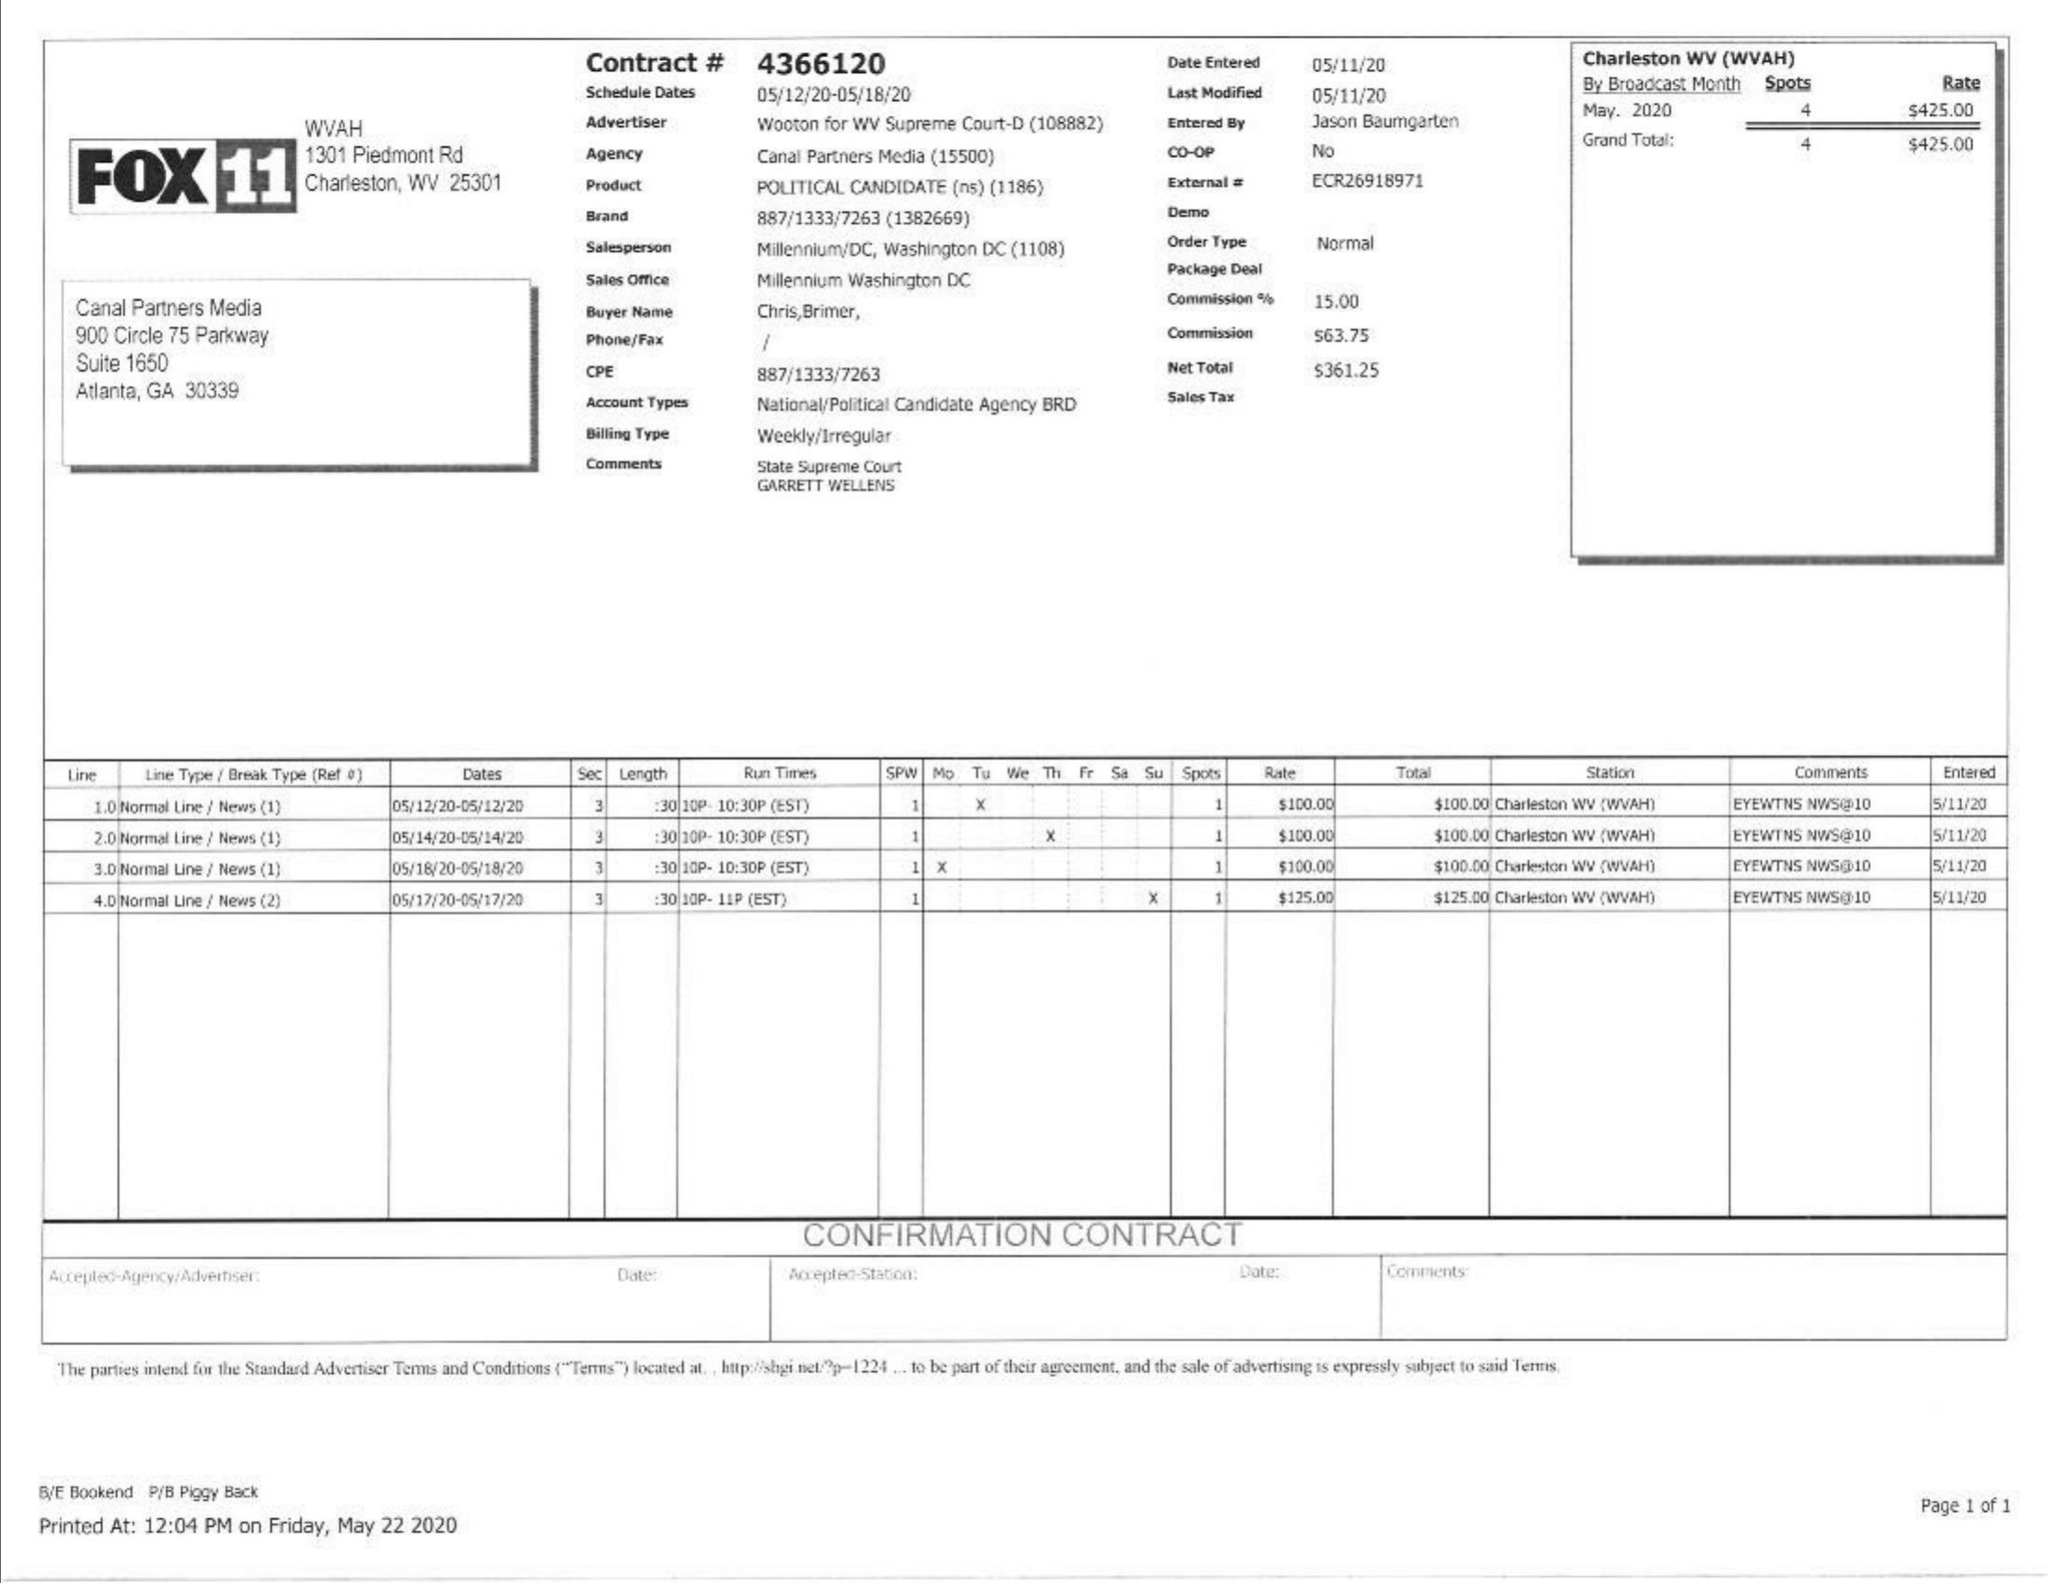What is the value for the contract_num?
Answer the question using a single word or phrase. 4366120 